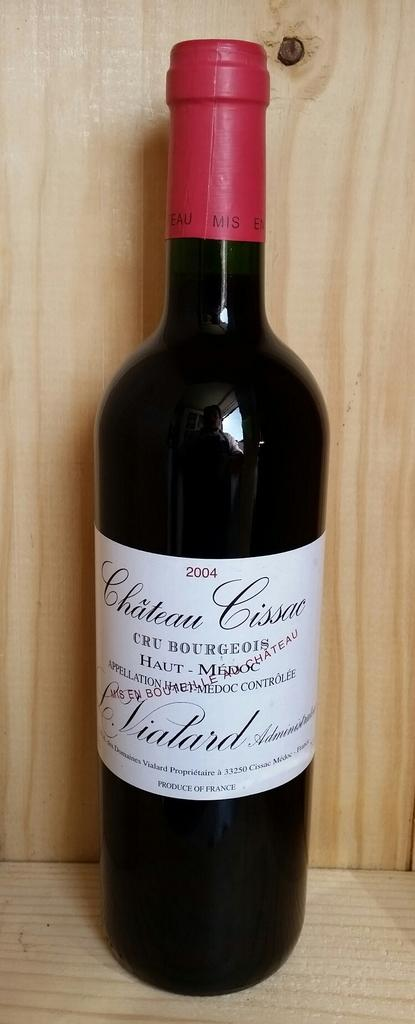<image>
Share a concise interpretation of the image provided. A bottle of wine says Chateau on a wooden shelf. 